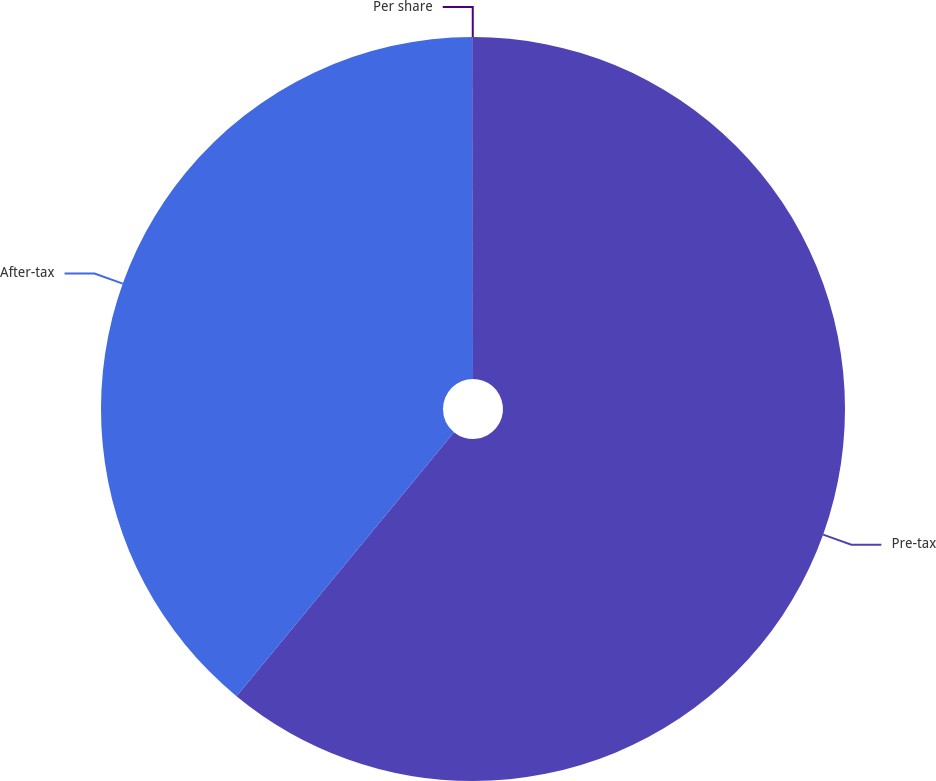<chart> <loc_0><loc_0><loc_500><loc_500><pie_chart><fcel>Pre-tax<fcel>After-tax<fcel>Per share<nl><fcel>60.96%<fcel>39.01%<fcel>0.02%<nl></chart> 